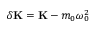Convert formula to latex. <formula><loc_0><loc_0><loc_500><loc_500>\delta K = K - m _ { 0 } \omega _ { 0 } ^ { 2 }</formula> 